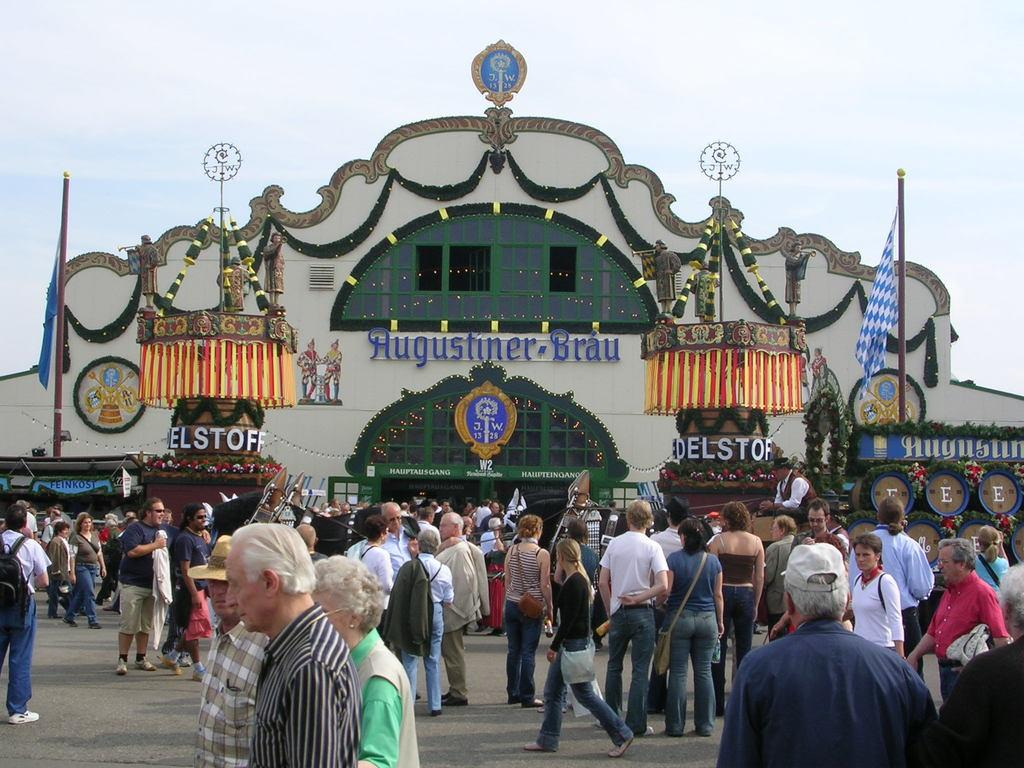What is happening in the image? There are people standing in the image. Where are the people standing? The people are standing on a floor. What can be seen in the background of the image? There is a building and flagpoles in the background of the image. Where is the guide leading the people in the image? There is no guide present in the image, so it is not possible to determine where they might be leading the people. 